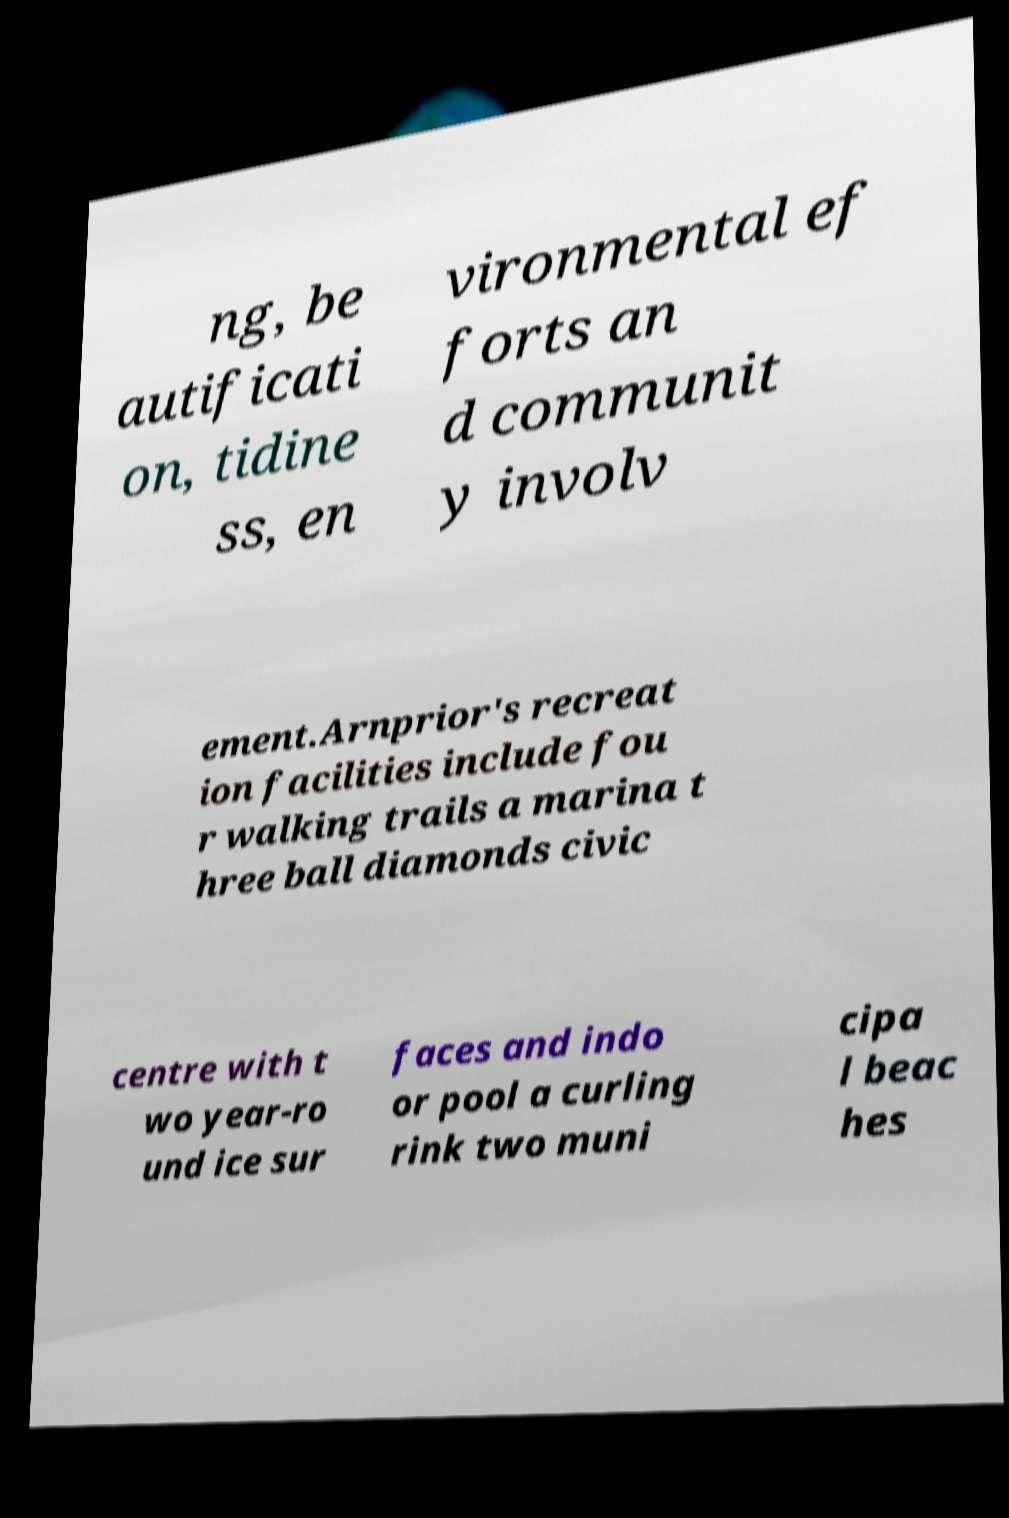Can you read and provide the text displayed in the image?This photo seems to have some interesting text. Can you extract and type it out for me? ng, be autificati on, tidine ss, en vironmental ef forts an d communit y involv ement.Arnprior's recreat ion facilities include fou r walking trails a marina t hree ball diamonds civic centre with t wo year-ro und ice sur faces and indo or pool a curling rink two muni cipa l beac hes 